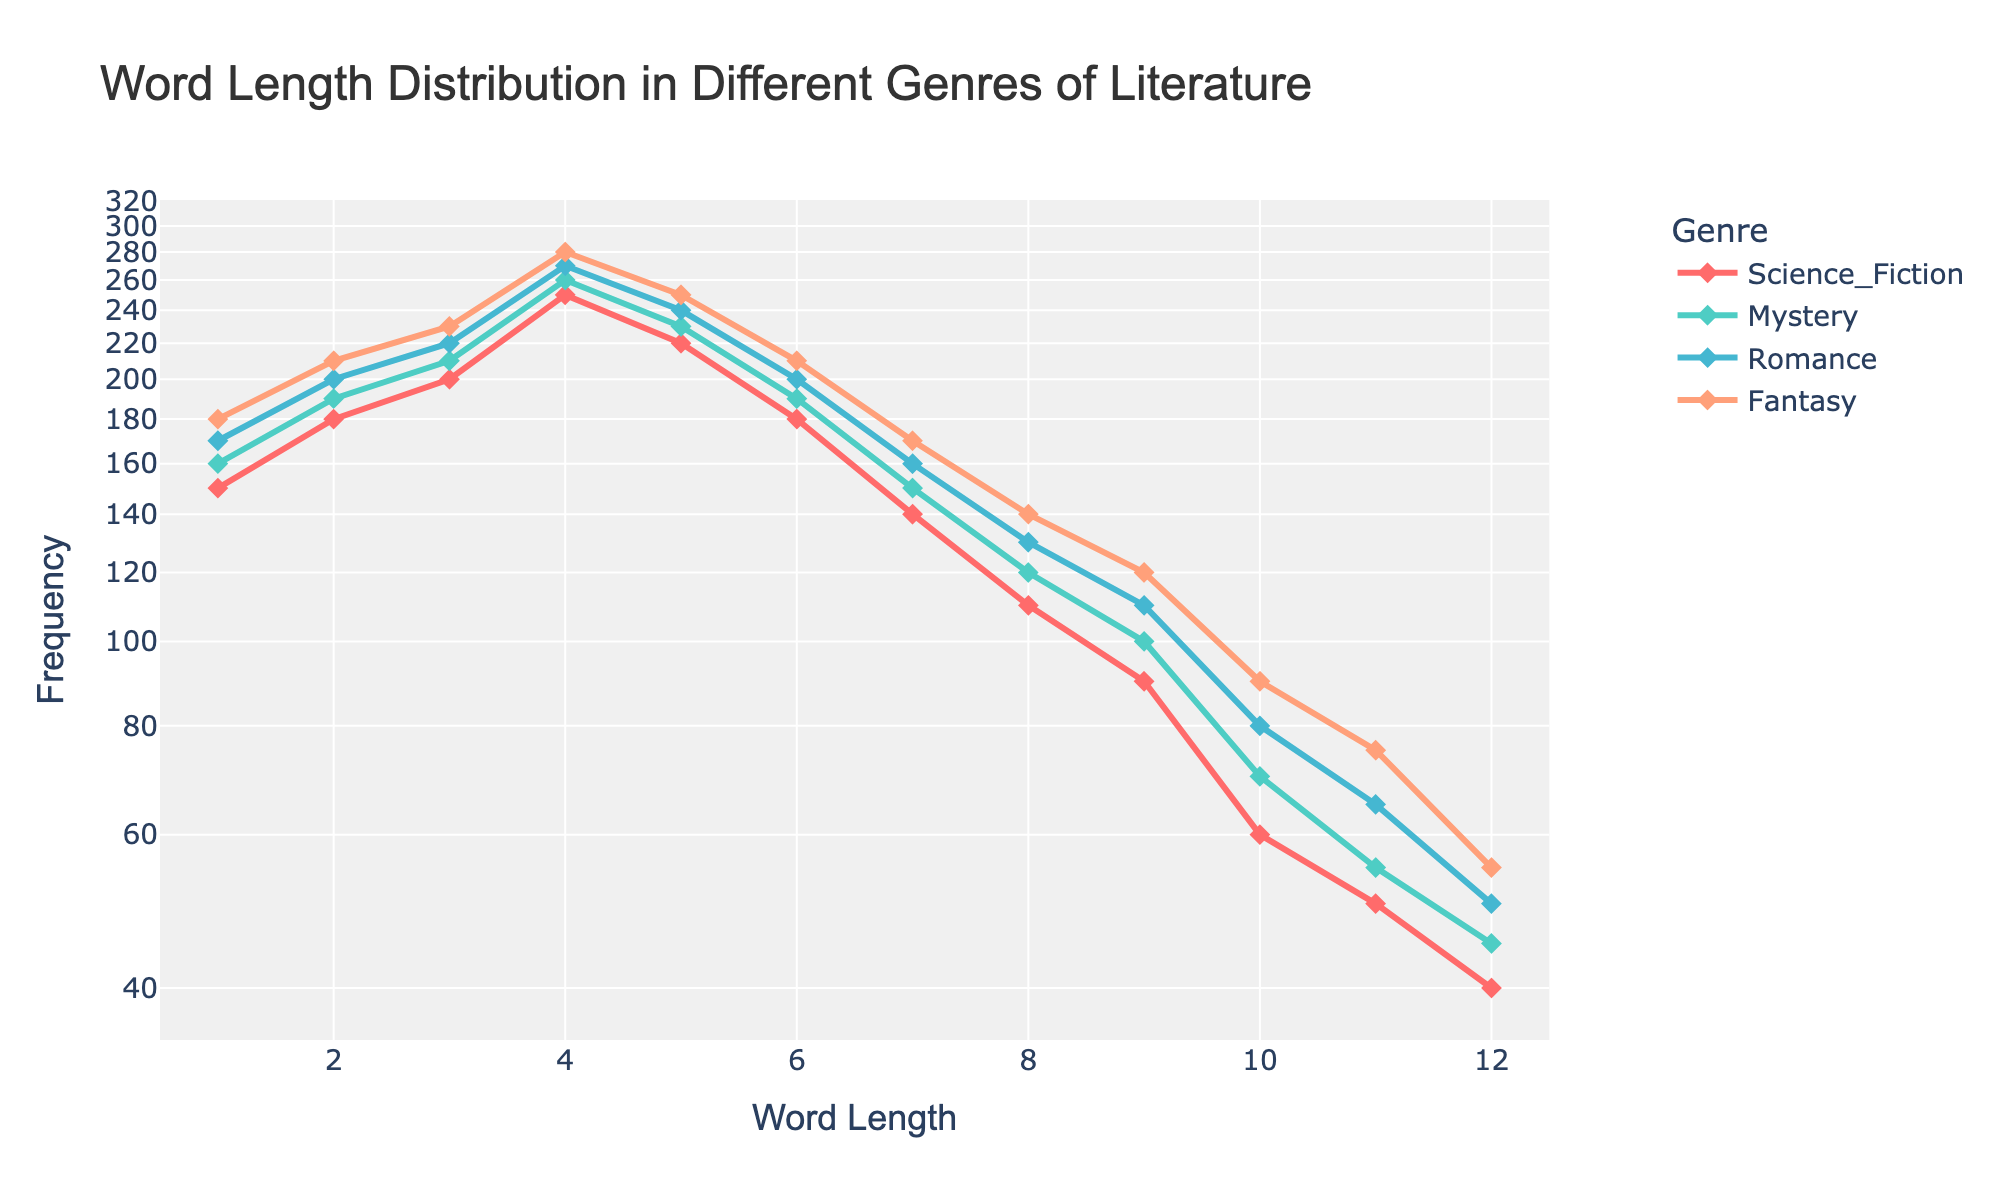What is the title of the figure? The title of the figure is written at the top of the plot and provides a summary of what the figure represents.
Answer: Word Length Distribution in Different Genres of Literature How many genres are compared in the plot? Count the number of unique lines representing different genres. Different colors and legends help to identify them.
Answer: 4 What is the range of the x-axis in the figure? Look at the labels at the bottom of the plot to identify the smallest and largest numbers representing word lengths.
Answer: 1 to 12 Which genre has the highest frequency for word length 1? Observe the points corresponding to word length 1 and compare their heights, identifying the genre with the highest point.
Answer: Fantasy At word length 5, which genre has a lower frequency: Mystery or Romance? Look at the points for word length 5 in both the Mystery (230) and Romance (240) data series, and compare their heights visually.
Answer: Mystery What is the general trend in word frequency as word length increases for all genres? Analyze the overall slope of the lines for each genre. They all generally decline as word length increases.
Answer: Decreases How does the frequency of word length 4 compare across all genres? For each genre, find the data points for word length 4 and compare their heights. The genres Science_Fiction (250), Mystery (260), Romance (270), and Fantasy (280) are ordered by increasing height.
Answer: Fantasy > Romance > Mystery > Science_Fiction 